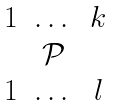Convert formula to latex. <formula><loc_0><loc_0><loc_500><loc_500>\begin{matrix} 1 & \dots & k \\ & \mathcal { P } & \\ 1 & \dots & l \end{matrix}</formula> 